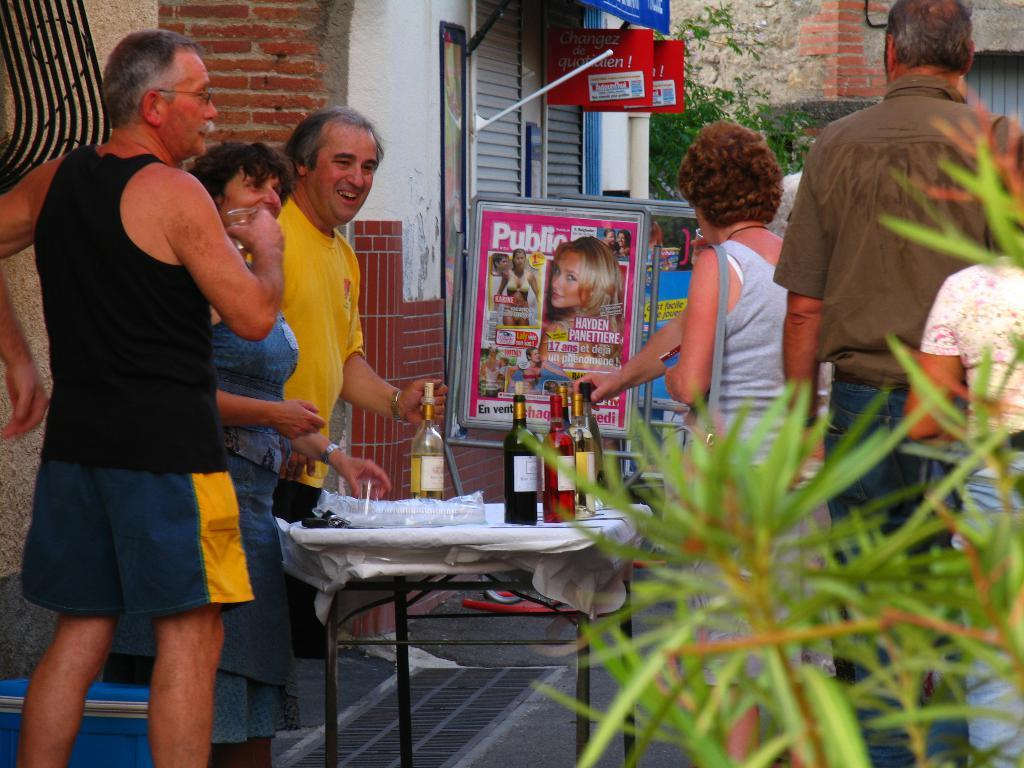<image>
Give a short and clear explanation of the subsequent image. a group of people outside with a Public magazine near them 